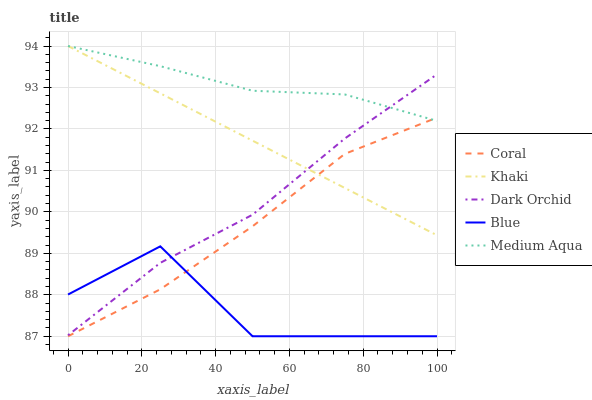Does Blue have the minimum area under the curve?
Answer yes or no. Yes. Does Medium Aqua have the maximum area under the curve?
Answer yes or no. Yes. Does Coral have the minimum area under the curve?
Answer yes or no. No. Does Coral have the maximum area under the curve?
Answer yes or no. No. Is Khaki the smoothest?
Answer yes or no. Yes. Is Blue the roughest?
Answer yes or no. Yes. Is Coral the smoothest?
Answer yes or no. No. Is Coral the roughest?
Answer yes or no. No. Does Blue have the lowest value?
Answer yes or no. Yes. Does Khaki have the lowest value?
Answer yes or no. No. Does Medium Aqua have the highest value?
Answer yes or no. Yes. Does Coral have the highest value?
Answer yes or no. No. Is Coral less than Dark Orchid?
Answer yes or no. Yes. Is Dark Orchid greater than Coral?
Answer yes or no. Yes. Does Khaki intersect Dark Orchid?
Answer yes or no. Yes. Is Khaki less than Dark Orchid?
Answer yes or no. No. Is Khaki greater than Dark Orchid?
Answer yes or no. No. Does Coral intersect Dark Orchid?
Answer yes or no. No. 